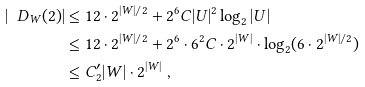Convert formula to latex. <formula><loc_0><loc_0><loc_500><loc_500>| \ D _ { W } ( 2 ) | & \leq 1 2 \cdot 2 ^ { | W | / 2 } + 2 ^ { 6 } C | U | ^ { 2 } \log _ { 2 } | U | \\ & \leq 1 2 \cdot 2 ^ { | W | / 2 } + 2 ^ { 6 } \cdot 6 ^ { 2 } C \cdot 2 ^ { | W | } \cdot \log _ { 2 } ( 6 \cdot 2 ^ { | W | / 2 } ) \\ & \leq C ^ { \prime } _ { 2 } | W | \cdot 2 ^ { | W | } \ ,</formula> 